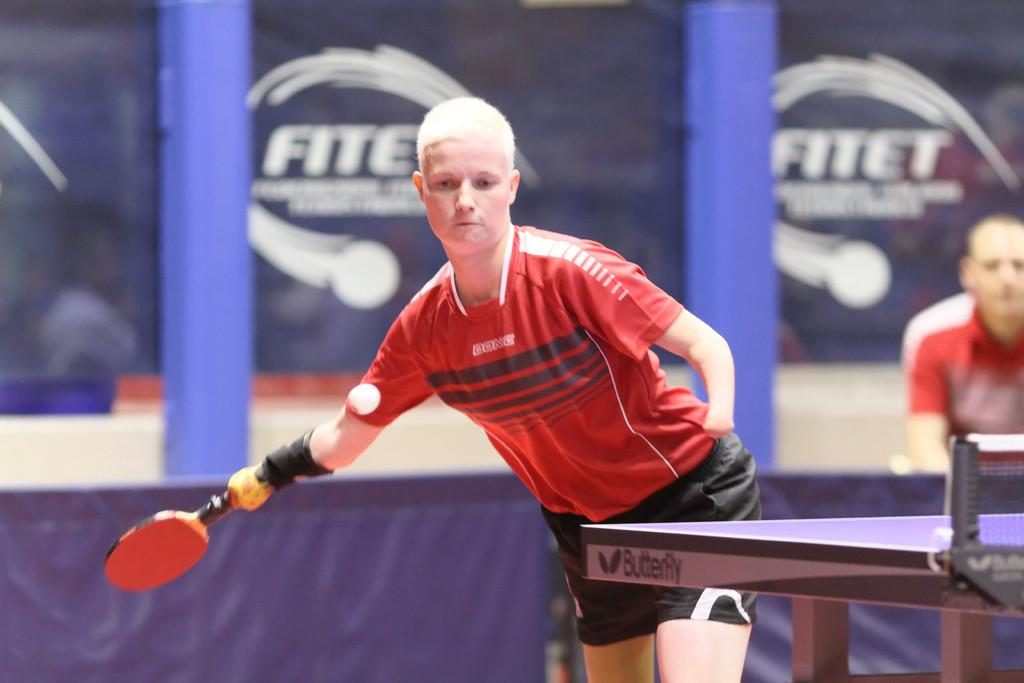What is the person in the image doing? The person is standing and holding a racket in their hand. What objects are present in the image besides the person? There is a table and a net in the image. What type of hammer is the person using to hit the ball in the image? There is no hammer present in the image, and the person is not using a hammer to hit the ball. 